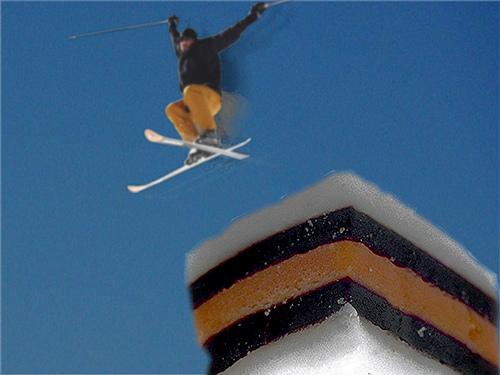Does this person have a better than average chance of suffering a grievous injury?
Short answer required. Yes. What color are the man's pants?
Short answer required. Yellow. What color is the sky?
Keep it brief. Blue. 